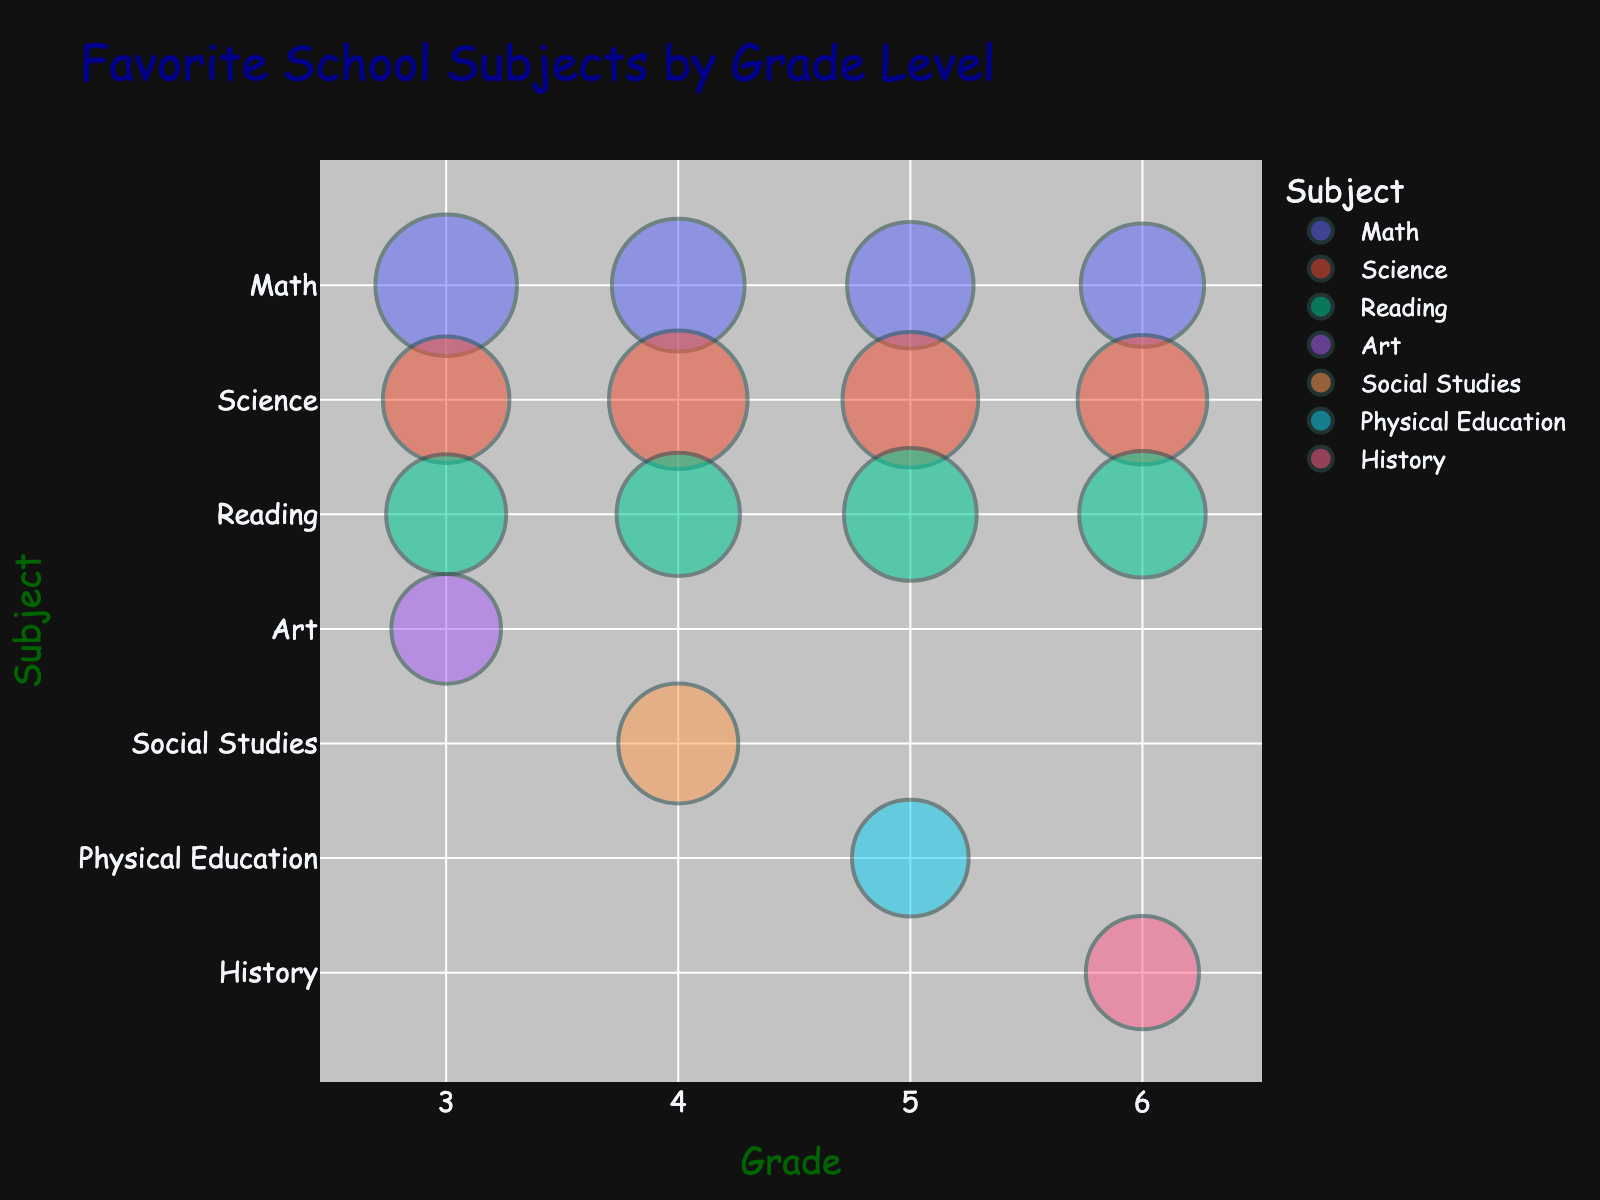What is the title of the bubble chart? The title of the bubble chart is usually displayed at the top of the figure. In this case, the title "Favorite School Subjects by Grade Level" is likely shown there.
Answer: Favorite School Subjects by Grade Level How many grade levels are represented in the chart? Look at the x-axis of the bubble chart, which represents the grade levels. The unique values present will indicate the number of grade levels.
Answer: 4 Which subject has the largest bubble in grade 3? To find this, look at the y-axis for subjects in grade 3 and compare the size of all bubbles. The largest bubble corresponds to the subject with the most students.
Answer: Math Which grade level has the smallest number of students for the subject 'Reading'? Look at the bubbles where the y-axis is "Reading" and compare their sizes. The smallest bubble indicates the smallest number of students.
Answer: Grade 3 Which subject is the most popular among 5th graders? For Grade 5 on the x-axis, observe the sizes of the bubbles and identify the largest one. The subject represented by this bubble is the most popular among 5th graders.
Answer: Science Compare the number of students interested in 'Science' between grade 4 and grade 5. Find the bubbles for 'Science' in grades 4 and 5, then compare their sizes. The size of the bubble indicates the number of students.
Answer: 24 (grade 4) and 23 (grade 5) What is the total number of students who favor 'Math' across all grades? Add up the number of students for 'Math' in each grade: 25 (grade 3) + 22 (grade 4) + 20 (grade 5) + 19 (grade 6).
Answer: 86 Which grade level has the least favorite subject, and what is that subject? Look for the smallest bubble in each grade level, then compare these bubbles to find the smallest one overall.
Answer: Art in Grade 3 Is the interest in 'Science' increasing or decreasing from grade 3 to grade 6? Identify the bubbles for 'Science' across grades 3 to 6 and observe any trends in their sizes. The change in size indicates increasing or decreasing interest.
Answer: Decreasing How many subjects are uniquely present in grade 6 but not in grade 3? Compare the subjects listed on the y-axis for grades 6 and 3. Count the number of subjects unique to grade 6.
Answer: 1 (History) 